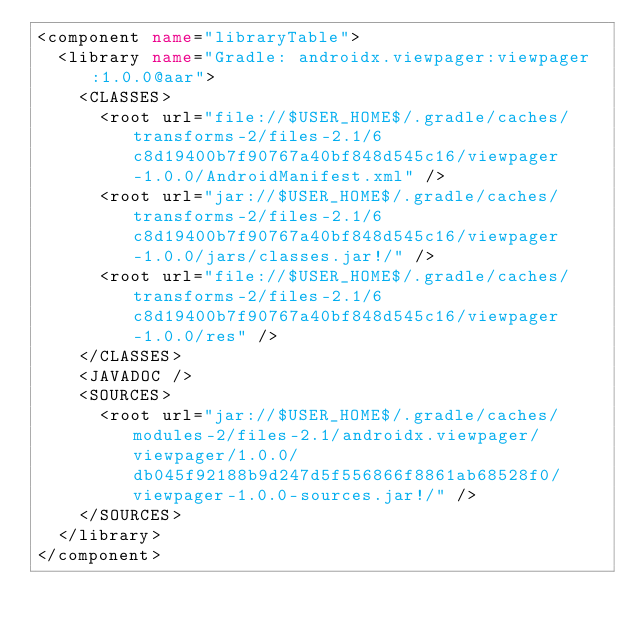<code> <loc_0><loc_0><loc_500><loc_500><_XML_><component name="libraryTable">
  <library name="Gradle: androidx.viewpager:viewpager:1.0.0@aar">
    <CLASSES>
      <root url="file://$USER_HOME$/.gradle/caches/transforms-2/files-2.1/6c8d19400b7f90767a40bf848d545c16/viewpager-1.0.0/AndroidManifest.xml" />
      <root url="jar://$USER_HOME$/.gradle/caches/transforms-2/files-2.1/6c8d19400b7f90767a40bf848d545c16/viewpager-1.0.0/jars/classes.jar!/" />
      <root url="file://$USER_HOME$/.gradle/caches/transforms-2/files-2.1/6c8d19400b7f90767a40bf848d545c16/viewpager-1.0.0/res" />
    </CLASSES>
    <JAVADOC />
    <SOURCES>
      <root url="jar://$USER_HOME$/.gradle/caches/modules-2/files-2.1/androidx.viewpager/viewpager/1.0.0/db045f92188b9d247d5f556866f8861ab68528f0/viewpager-1.0.0-sources.jar!/" />
    </SOURCES>
  </library>
</component></code> 